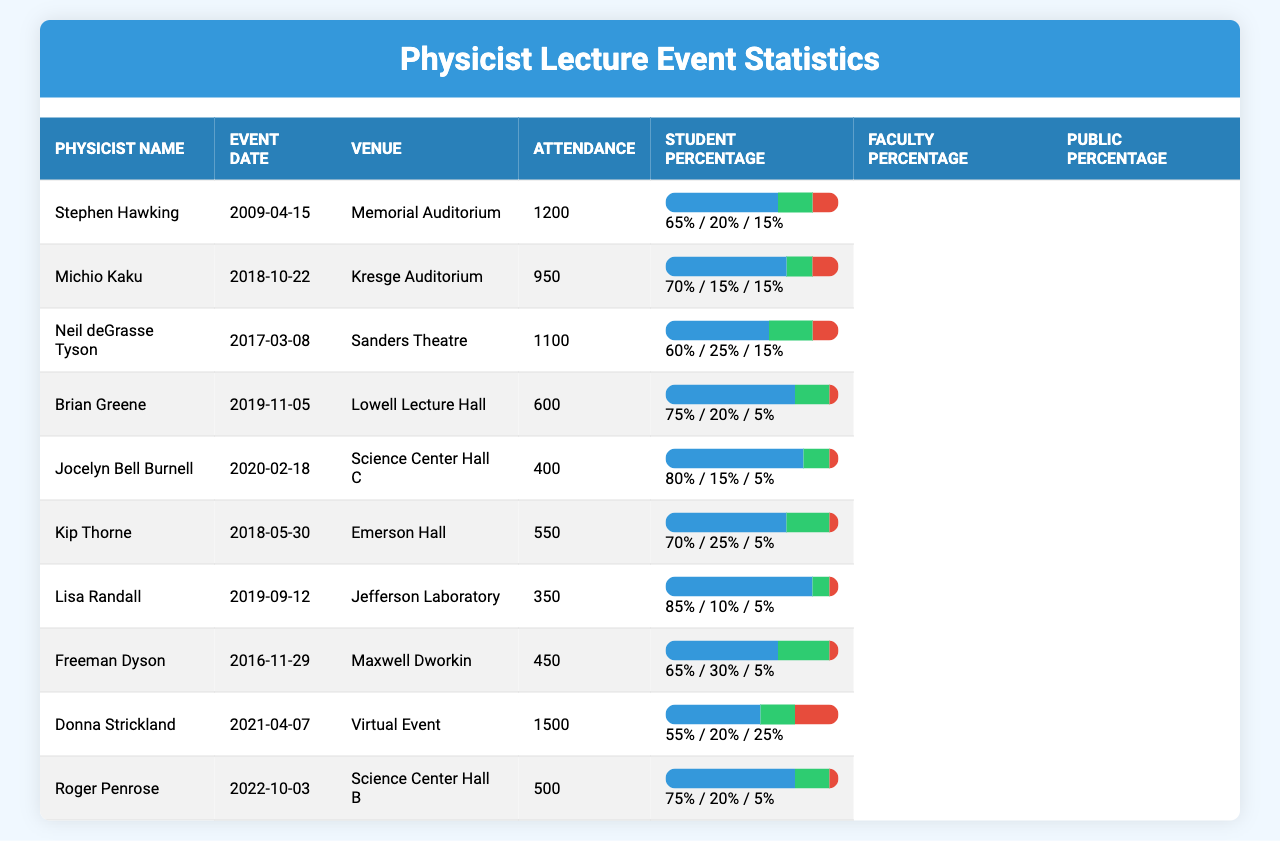What is the highest attendance recorded for a physicist lecture? The maximum value in the Attendance column is 1500, which corresponds to the event held by Donna Strickland on April 7, 2021.
Answer: 1500 Who had the lowest attendance at their lecture? Looking at the Attendance column, the lowest value is 350, which corresponds to Lisa Randall's lecture on September 12, 2019.
Answer: 350 Which physicist had the highest percentage of students attending their lecture? By checking the Student Percentage column, Jocelyn Bell Burnell had the highest student percentage at 80%.
Answer: 80% How many physicists had an attendance of over 1000? Counting the figures in the Attendance column, three physicists had attendance numbers over 1000: Stephen Hawking, Neil deGrasse Tyson, and Donna Strickland.
Answer: 3 What is the average attendance across all listed events? Adding all attendance figures (1200 + 950 + 1100 + 600 + 400 + 550 + 350 + 450 + 1500 + 500) gives 6250. There are 10 events, so the average is 6250/10 = 625.
Answer: 625 Did any physicist events have more faculty attendees than student attendees? Checking the Faculty Percentage and Student Percentage for each physicist, only Freeman Dyson has 30% faculty and 65% student, making it no. So, an event with more faculty attendees does not exist.
Answer: No Which event had the largest percentage of public attendance? When reviewing the Public Percentage column, the highest value is 25%, which corresponds to Donna Strickland's lecture.
Answer: 25% What is the total percentage of students and faculty participants across all events? The total percentage is calculated by summing the Student Percentage and Faculty Percentage for each event. The sum is (65 + 70 + 60 + 75 + 80 + 70 + 85 + 65 + 55 + 75) =  745, and the Faculty total is (20 + 15 + 25 + 20 + 15 + 25 + 10 + 30 + 20 + 20) =  165, resulting in 910.
Answer: 910 Which physicist had the lowest percentage of public attendance? By examining the Public Percentage column, Lisa Randall had the lowest public attendance percentage at 5%.
Answer: 5% What percentage of attendees at Michio Kaku's event were faculty members? Looking at Michio Kaku's row, the Faculty Percentage is given as 15%.
Answer: 15 